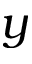Convert formula to latex. <formula><loc_0><loc_0><loc_500><loc_500>y</formula> 